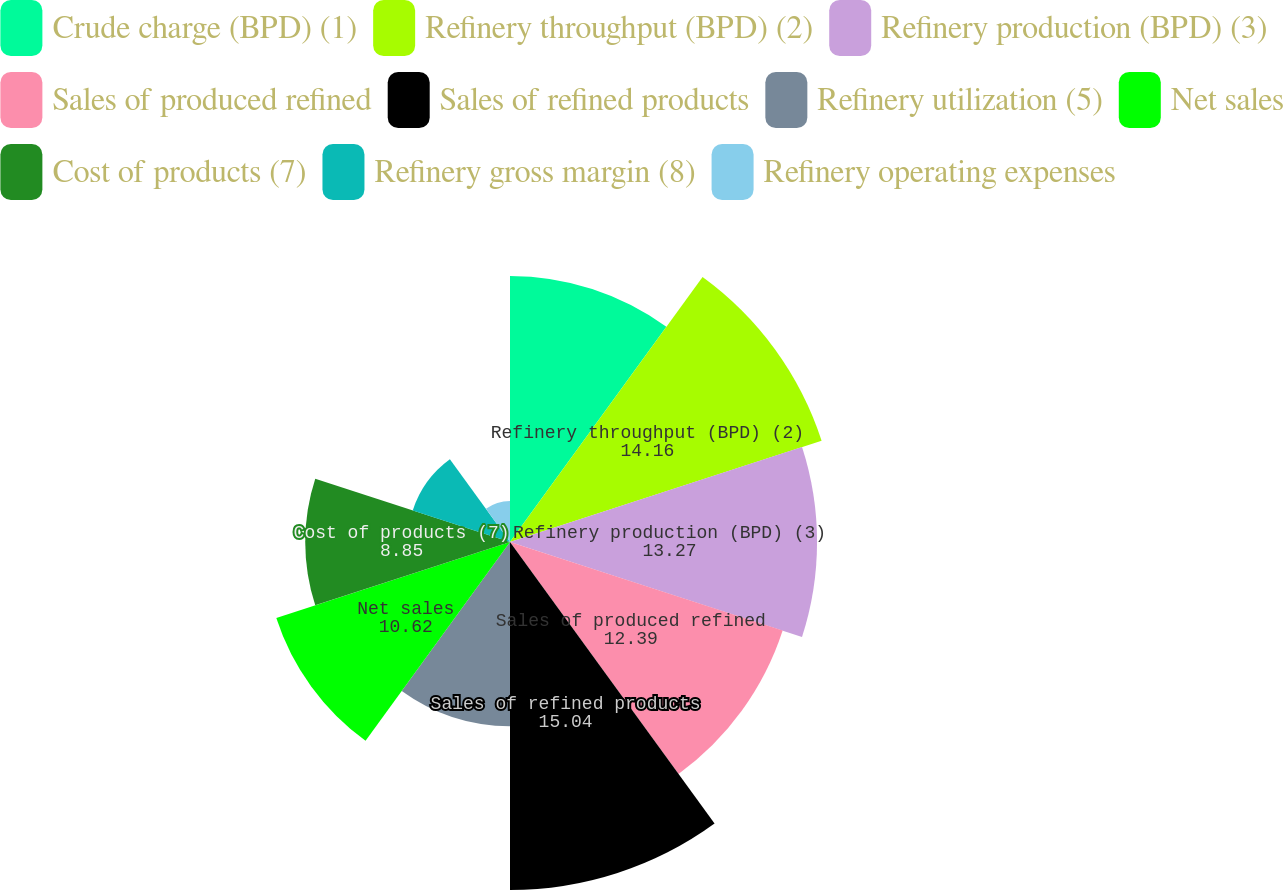Convert chart. <chart><loc_0><loc_0><loc_500><loc_500><pie_chart><fcel>Crude charge (BPD) (1)<fcel>Refinery throughput (BPD) (2)<fcel>Refinery production (BPD) (3)<fcel>Sales of produced refined<fcel>Sales of refined products<fcel>Refinery utilization (5)<fcel>Net sales<fcel>Cost of products (7)<fcel>Refinery gross margin (8)<fcel>Refinery operating expenses<nl><fcel>11.5%<fcel>14.16%<fcel>13.27%<fcel>12.39%<fcel>15.04%<fcel>7.96%<fcel>10.62%<fcel>8.85%<fcel>4.42%<fcel>1.77%<nl></chart> 